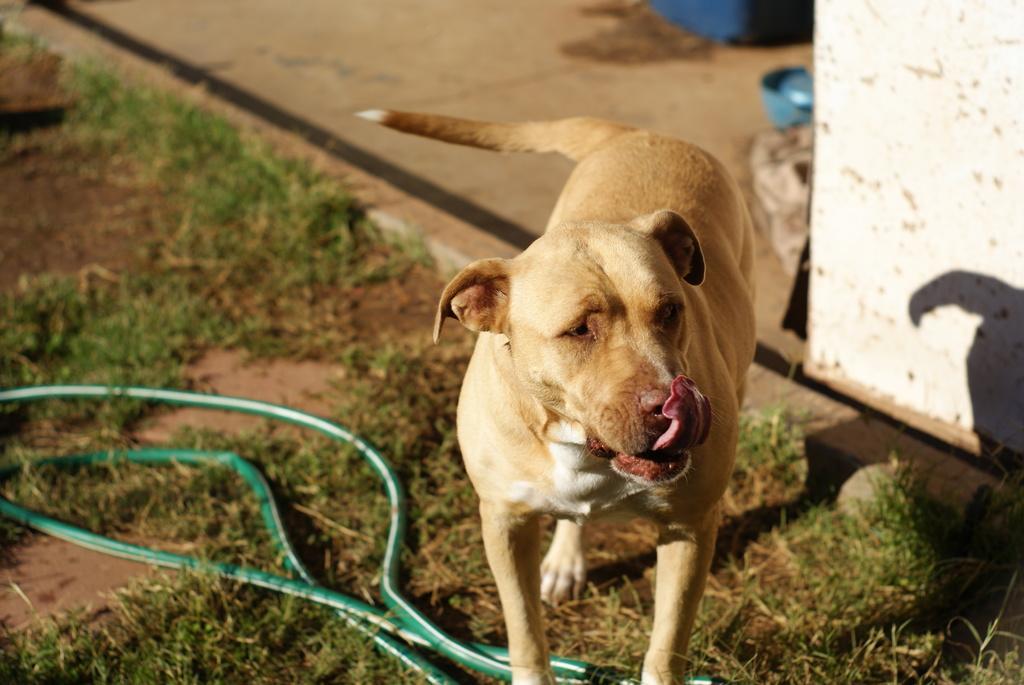Can you describe this image briefly? In this picture I can observe a dog standing on the land. This dog is in cream color. I can observe green color pipe on the ground. On the right side there is a wall. 